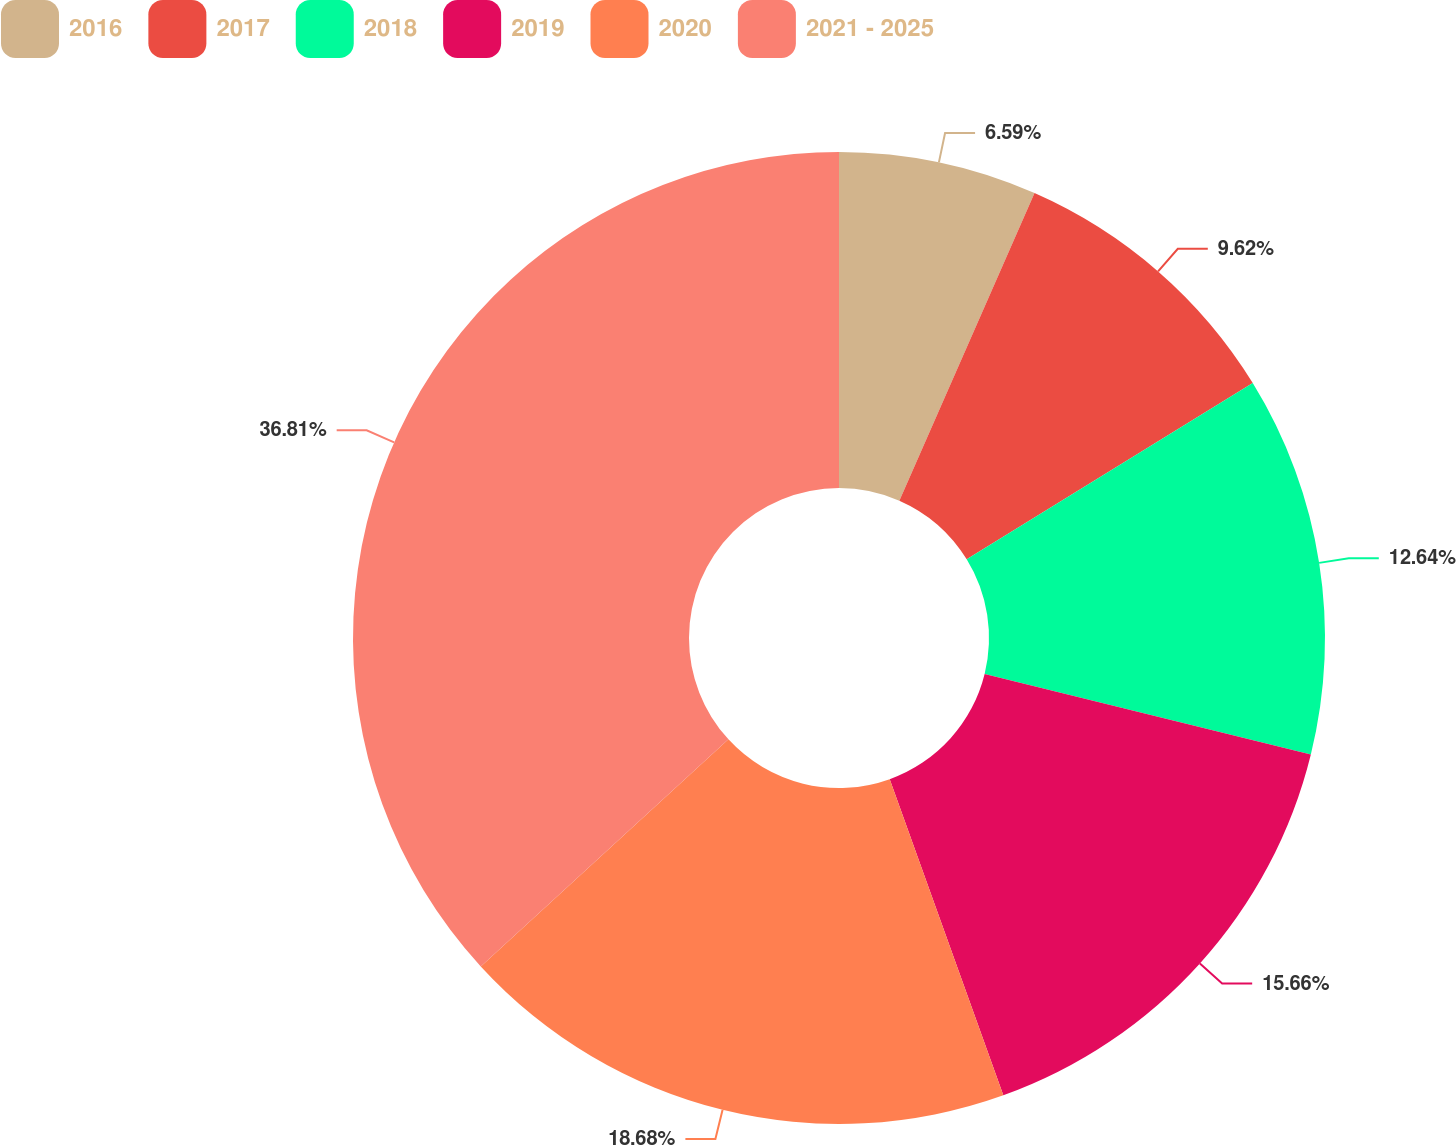<chart> <loc_0><loc_0><loc_500><loc_500><pie_chart><fcel>2016<fcel>2017<fcel>2018<fcel>2019<fcel>2020<fcel>2021 - 2025<nl><fcel>6.59%<fcel>9.62%<fcel>12.64%<fcel>15.66%<fcel>18.68%<fcel>36.81%<nl></chart> 